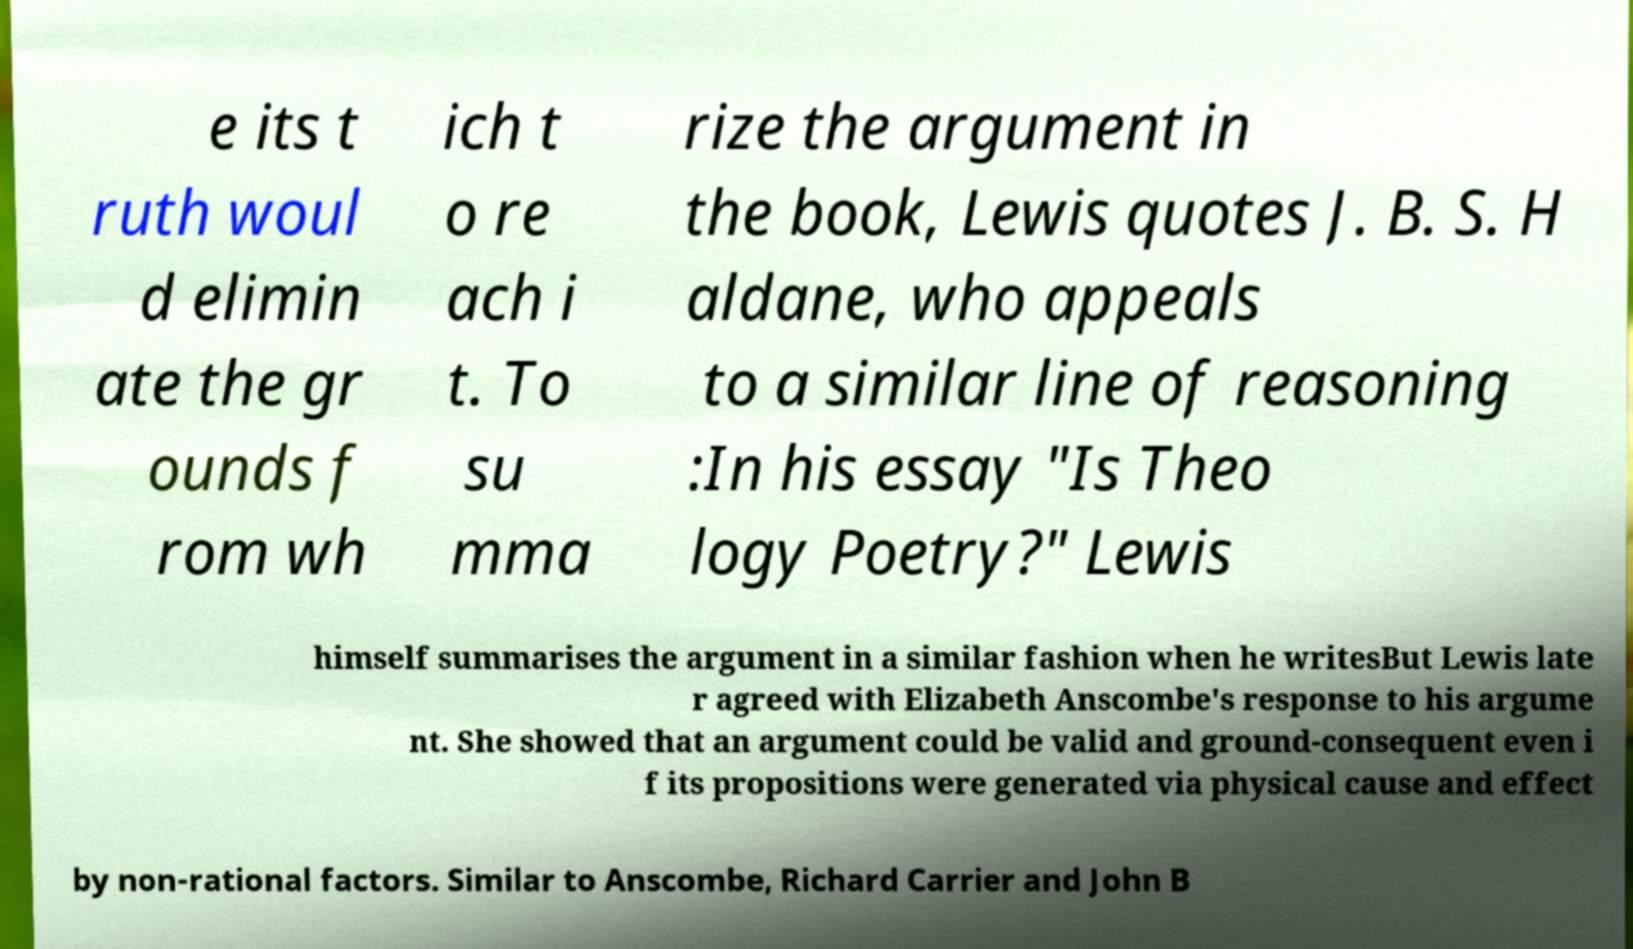What messages or text are displayed in this image? I need them in a readable, typed format. e its t ruth woul d elimin ate the gr ounds f rom wh ich t o re ach i t. To su mma rize the argument in the book, Lewis quotes J. B. S. H aldane, who appeals to a similar line of reasoning :In his essay "Is Theo logy Poetry?" Lewis himself summarises the argument in a similar fashion when he writesBut Lewis late r agreed with Elizabeth Anscombe's response to his argume nt. She showed that an argument could be valid and ground-consequent even i f its propositions were generated via physical cause and effect by non-rational factors. Similar to Anscombe, Richard Carrier and John B 